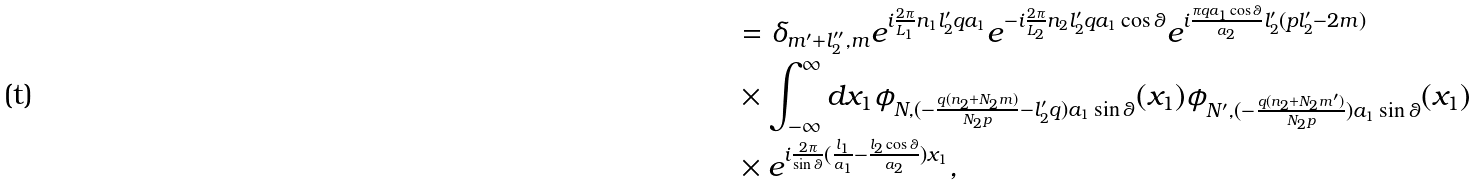Convert formula to latex. <formula><loc_0><loc_0><loc_500><loc_500>& = \delta _ { m ^ { \prime } + l _ { 2 } ^ { \prime \prime } , m } e ^ { i \frac { 2 \pi } { L _ { 1 } } n _ { 1 } l _ { 2 } ^ { \prime } q a _ { 1 } } e ^ { - i \frac { 2 \pi } { L _ { 2 } } n _ { 2 } l _ { 2 } ^ { \prime } q a _ { 1 } \cos \theta } e ^ { i \frac { \pi q a _ { 1 } \cos \theta } { a _ { 2 } } l _ { 2 } ^ { \prime } ( p l _ { 2 } ^ { \prime } - 2 m ) } \\ & \times \int _ { - \infty } ^ { \infty } d x _ { 1 } \phi _ { N , ( - \frac { q ( n _ { 2 } + N _ { 2 } m ) } { N _ { 2 } p } - l _ { 2 } ^ { \prime } q ) a _ { 1 } \sin \theta } ( x _ { 1 } ) \phi _ { N ^ { \prime } , ( - \frac { q ( n _ { 2 } + N _ { 2 } m ^ { \prime } ) } { N _ { 2 } p } ) a _ { 1 } \sin \theta } ( x _ { 1 } ) \\ & \times e ^ { i \frac { 2 \pi } { \sin \theta } ( \frac { l _ { 1 } } { a _ { 1 } } - \frac { l _ { 2 } \cos \theta } { a _ { 2 } } ) x _ { 1 } } ,</formula> 